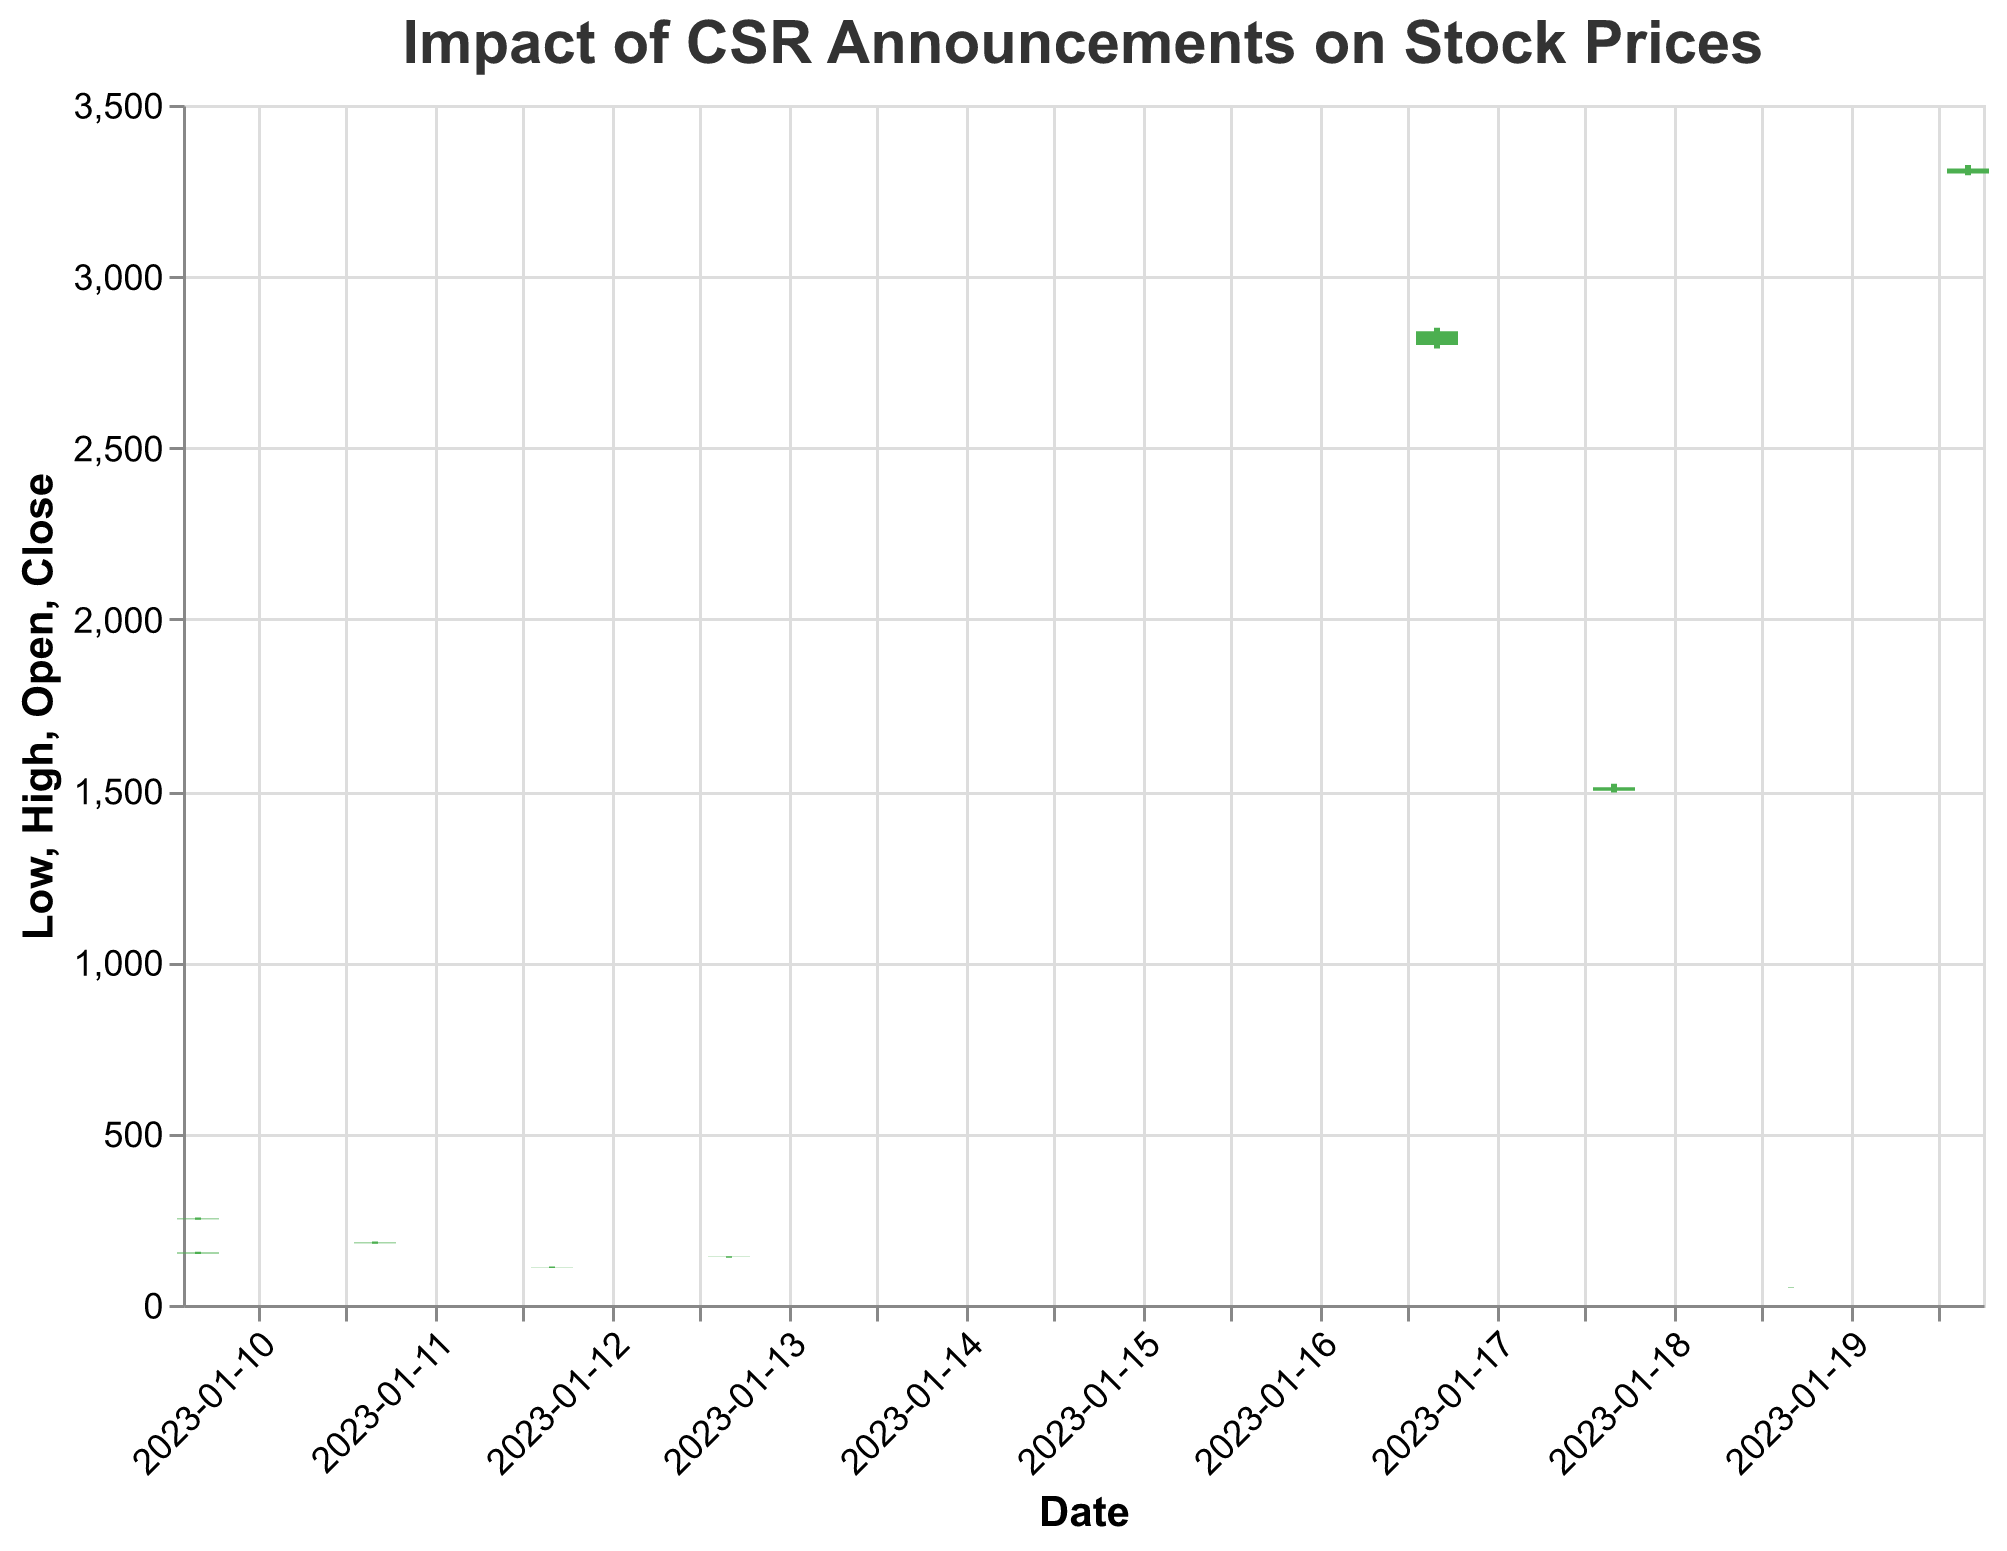What is the title of the candlestick plot? The title is displayed at the top of the plot and provides context for what the plot represents.
Answer: Impact of CSR Announcements on Stock Prices How did Amazon's stock price react to their Sustainability Report announcement? Look at the bar representing Amazon on January 20, 2023. The opening price is 3300.00, and the closing price is 3315.00, indicating a rise in stock price.
Answer: The stock price increased What is the color corresponding to a stock price increase? In candlestick plots, a color usually represents a gain or loss. Here, green indicates a rise.
Answer: Green Which company had the highest closing price following their CSR announcement? Compare the closing prices of all companies. Google has the highest closing price with 2840.00 on January 17.
Answer: Google LLC What was the lowest price recorded for Samsung Electronics Co on the day of their CSR announcement? Look at the "Low" value for Samsung on January 18, 2023. The lowest price recorded was 1495.00.
Answer: 1495.00 On which date did Microsoft announce its CSR initiative, and what was the closing stock price on that day? Find the date corresponding to Microsoft's CSR announcement and note the closing price for that day. Microsoft announced on January 10, 2023, and the closing price was 252.00.
Answer: January 10, 2023, and 252.00 Between Apple Inc and Microsoft Corp, which company had a higher trading volume on January 10, 2023? Compare the "Volume" values for Apple and Microsoft on January 10, 2023. Apple had a volume of 75,000,000, while Microsoft had a volume of 60,000,000.
Answer: Apple Inc What is the average closing price of the companies that announced CSR initiatives on January 10, 2023? Sum the closing prices of Apple and Microsoft on January 10 and divide by 2. The average is (153.00 + 252.00) / 2 = 202.50.
Answer: 202.50 Did any company have a lower closing price than its opening price following their CSR announcement? Check if the closing price is less than the opening price for any company. None of the companies had a lower closing price than their opening price.
Answer: No Which CSR announcement led to the highest stock price increase and what was the numerical difference? Determine the difference between the closing and opening prices for each company and find the maximum. Google LLC had the highest stock price increase: 2840.00 - 2800.00 = 40.00.
Answer: Google LLC with a 40.00 increase 